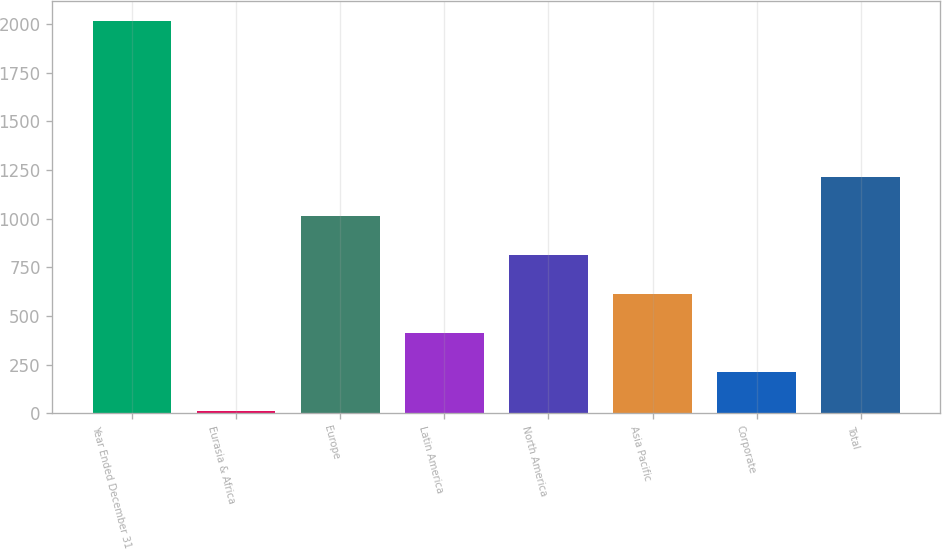<chart> <loc_0><loc_0><loc_500><loc_500><bar_chart><fcel>Year Ended December 31<fcel>Eurasia & Africa<fcel>Europe<fcel>Latin America<fcel>North America<fcel>Asia Pacific<fcel>Corporate<fcel>Total<nl><fcel>2015<fcel>11.3<fcel>1013.15<fcel>412.04<fcel>812.78<fcel>612.41<fcel>211.67<fcel>1213.52<nl></chart> 